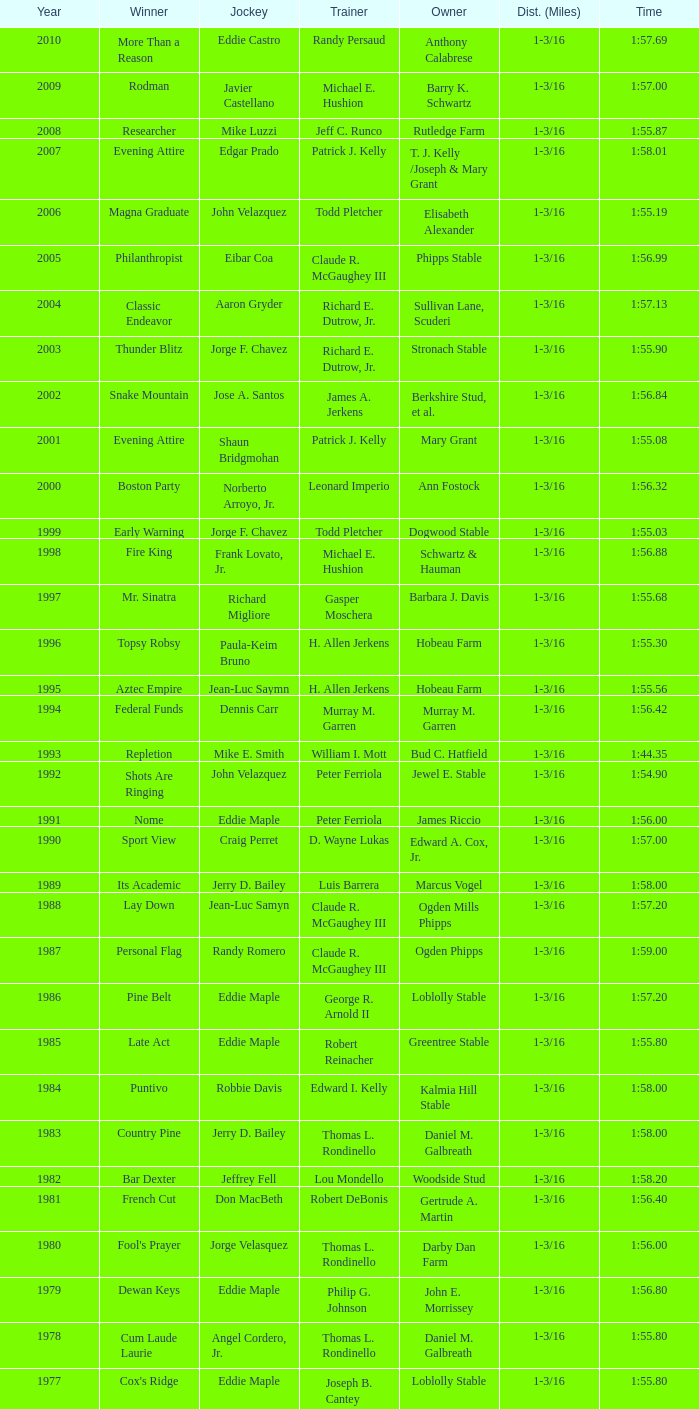When the winner was No Race in a year after 1909, what was the distance? 1 mile, 1 mile, 1 mile. 